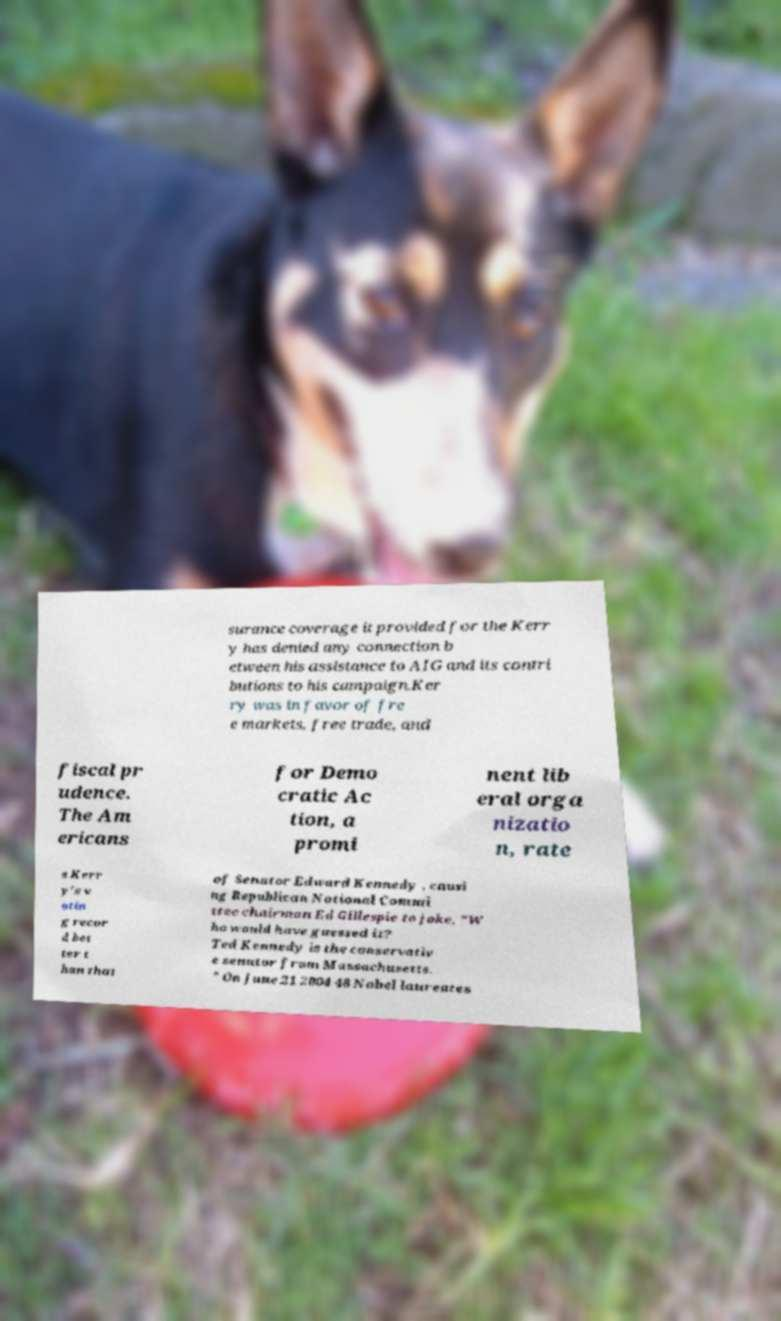Can you accurately transcribe the text from the provided image for me? surance coverage it provided for the Kerr y has denied any connection b etween his assistance to AIG and its contri butions to his campaign.Ker ry was in favor of fre e markets, free trade, and fiscal pr udence. The Am ericans for Demo cratic Ac tion, a promi nent lib eral orga nizatio n, rate s Kerr y's v otin g recor d bet ter t han that of Senator Edward Kennedy , causi ng Republican National Commi ttee chairman Ed Gillespie to joke, "W ho would have guessed it? Ted Kennedy is the conservativ e senator from Massachusetts. " On June 21 2004 48 Nobel laureates 